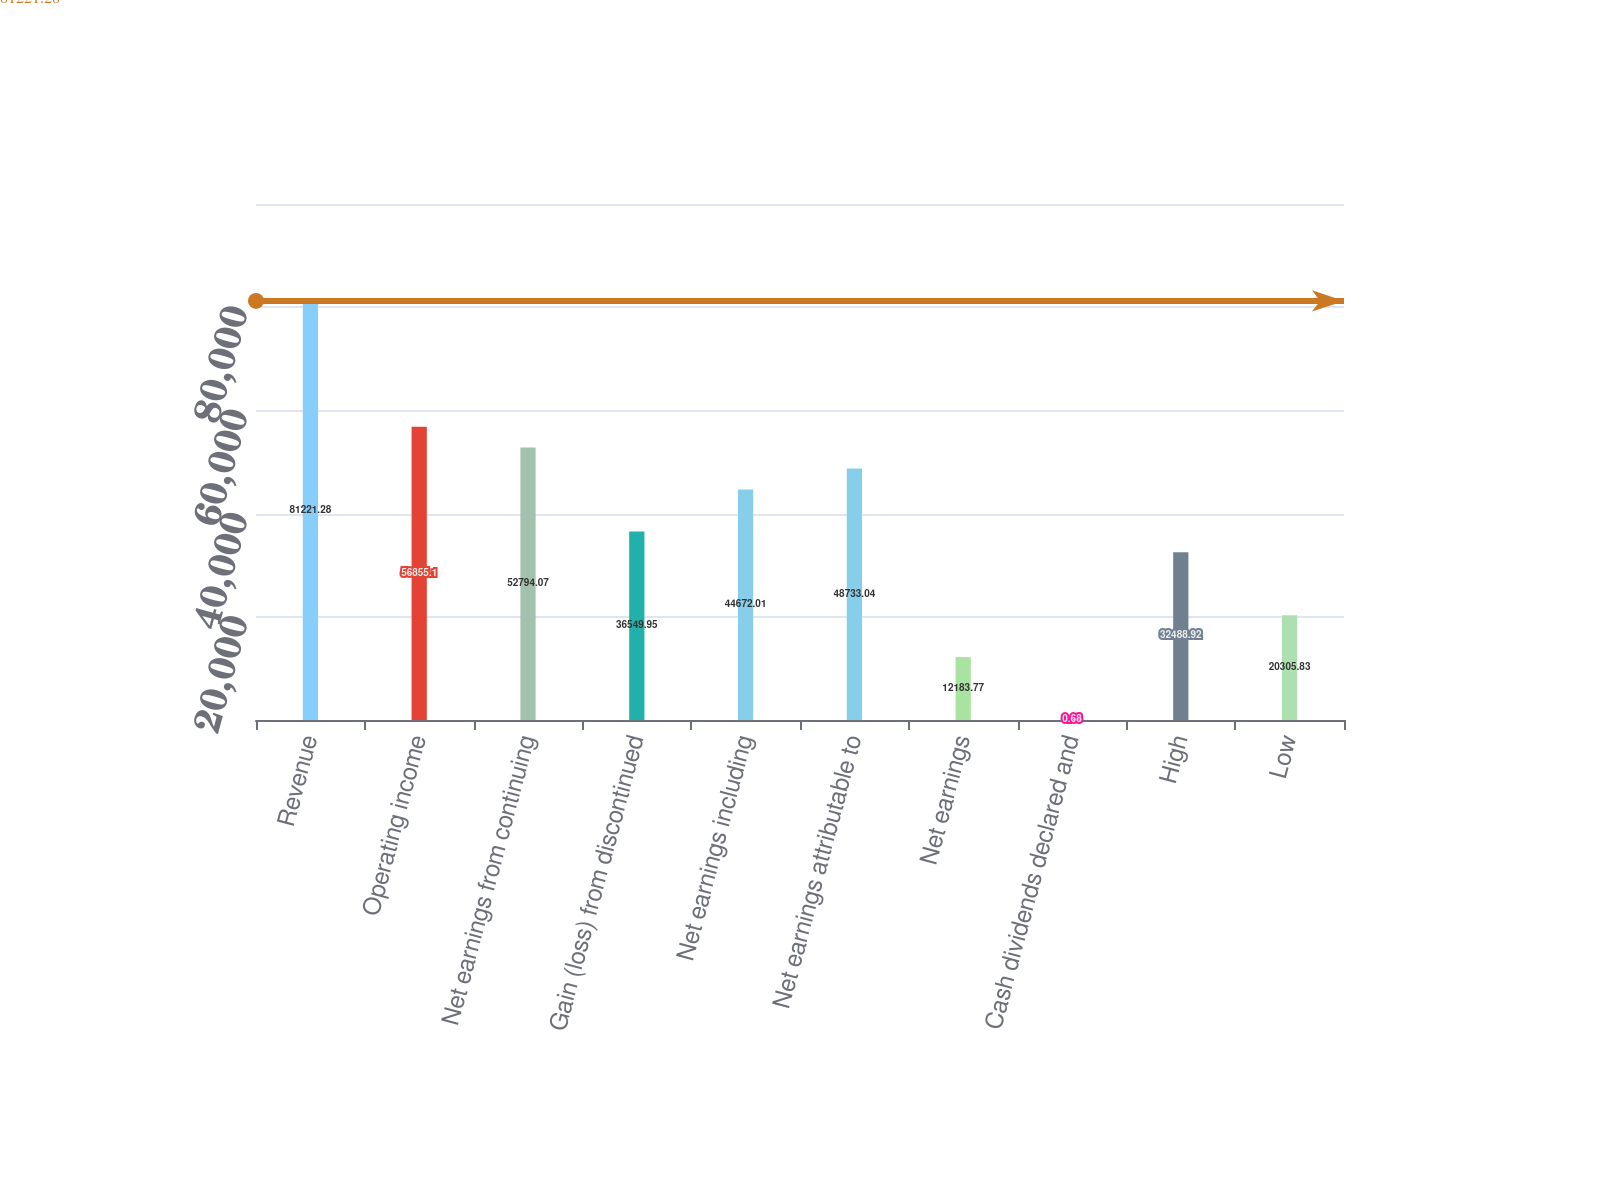Convert chart to OTSL. <chart><loc_0><loc_0><loc_500><loc_500><bar_chart><fcel>Revenue<fcel>Operating income<fcel>Net earnings from continuing<fcel>Gain (loss) from discontinued<fcel>Net earnings including<fcel>Net earnings attributable to<fcel>Net earnings<fcel>Cash dividends declared and<fcel>High<fcel>Low<nl><fcel>81221.3<fcel>56855.1<fcel>52794.1<fcel>36549.9<fcel>44672<fcel>48733<fcel>12183.8<fcel>0.68<fcel>32488.9<fcel>20305.8<nl></chart> 